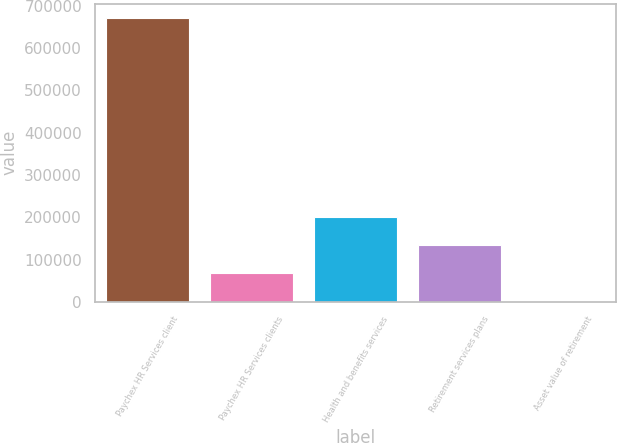Convert chart. <chart><loc_0><loc_0><loc_500><loc_500><bar_chart><fcel>Paychex HR Services client<fcel>Paychex HR Services clients<fcel>Health and benefits services<fcel>Retirement services plans<fcel>Asset value of retirement<nl><fcel>672000<fcel>67217.4<fcel>201614<fcel>134415<fcel>19.3<nl></chart> 